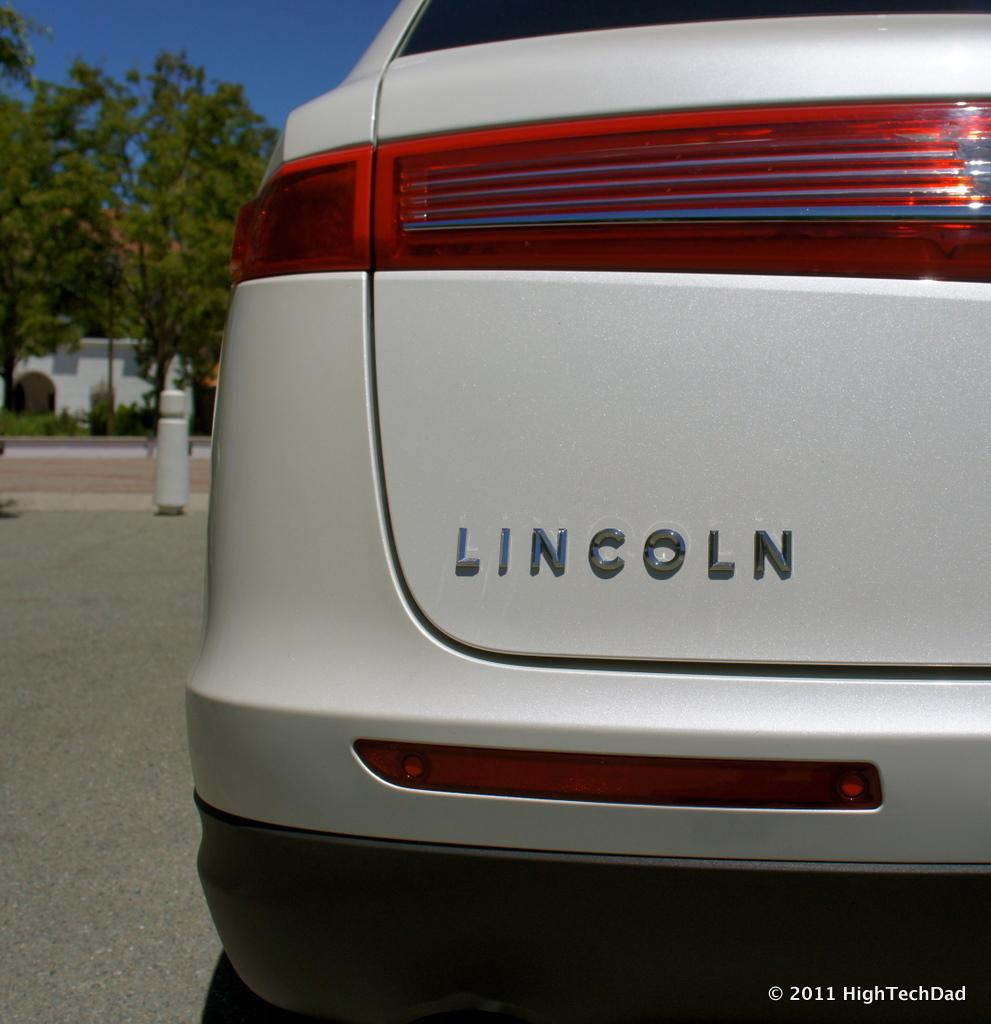What is the main subject of the image? The main subject of the image is a car. What other objects can be seen in the image? There are fencing poles, trees, and buildings visible in the image. What type of jar is being used to stitch the self in the image? There is no jar, self, or stitching present in the image. 